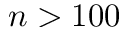Convert formula to latex. <formula><loc_0><loc_0><loc_500><loc_500>n > 1 0 0</formula> 